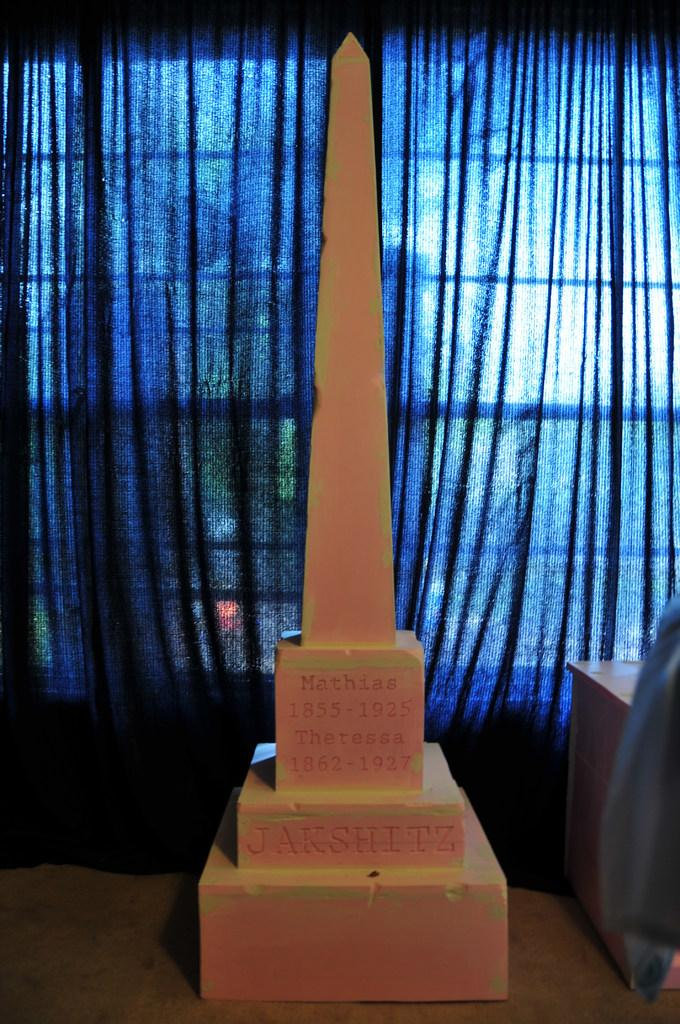What is the main object in the image? There is a pillar on a stand in the image. What can be seen on the pillar? Something is written on the pillar. What is visible in the background of the image? There is a curtain in the background of the image. What type of punishment is being administered to the robin in the image? There is no robin present in the image, and therefore no punishment is being administered. What mathematical operation is the calculator performing in the image? There is no calculator present in the image, so it is not possible to determine any mathematical operations being performed. 